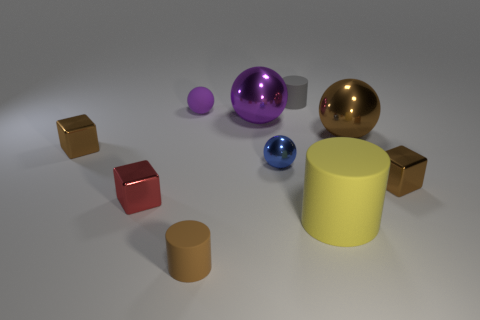What number of things are big brown balls or yellow shiny blocks?
Offer a very short reply. 1. Is there a metal sphere that has the same size as the yellow cylinder?
Make the answer very short. Yes. The yellow thing has what shape?
Ensure brevity in your answer.  Cylinder. Is the number of purple objects in front of the purple matte thing greater than the number of rubber cylinders in front of the large purple sphere?
Provide a succinct answer. No. Does the tiny cylinder that is behind the tiny red object have the same color as the tiny rubber object that is in front of the small purple matte object?
Offer a very short reply. No. The blue object that is the same size as the purple matte object is what shape?
Your answer should be very brief. Sphere. Are there any tiny brown things of the same shape as the purple rubber object?
Make the answer very short. No. Are the purple object that is left of the tiny brown cylinder and the big thing in front of the brown sphere made of the same material?
Your answer should be very brief. Yes. What shape is the object that is the same color as the rubber ball?
Keep it short and to the point. Sphere. How many red objects are the same material as the yellow cylinder?
Provide a succinct answer. 0. 